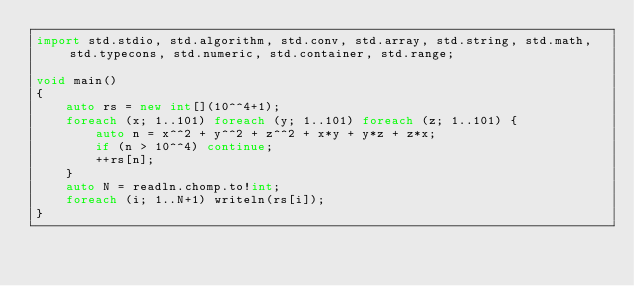<code> <loc_0><loc_0><loc_500><loc_500><_D_>import std.stdio, std.algorithm, std.conv, std.array, std.string, std.math, std.typecons, std.numeric, std.container, std.range;

void main()
{
    auto rs = new int[](10^^4+1);
    foreach (x; 1..101) foreach (y; 1..101) foreach (z; 1..101) {
        auto n = x^^2 + y^^2 + z^^2 + x*y + y*z + z*x;
        if (n > 10^^4) continue;
        ++rs[n];
    }
    auto N = readln.chomp.to!int;
    foreach (i; 1..N+1) writeln(rs[i]);
}</code> 